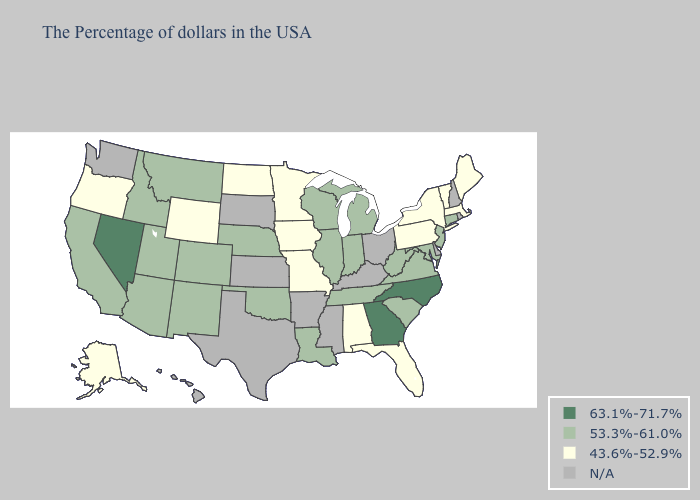What is the value of Indiana?
Keep it brief. 53.3%-61.0%. Does Minnesota have the highest value in the MidWest?
Write a very short answer. No. Does Alabama have the highest value in the USA?
Give a very brief answer. No. What is the highest value in the USA?
Short answer required. 63.1%-71.7%. What is the value of Kentucky?
Write a very short answer. N/A. What is the value of Kansas?
Answer briefly. N/A. Which states have the lowest value in the USA?
Write a very short answer. Maine, Massachusetts, Vermont, New York, Pennsylvania, Florida, Alabama, Missouri, Minnesota, Iowa, North Dakota, Wyoming, Oregon, Alaska. What is the highest value in the MidWest ?
Be succinct. 53.3%-61.0%. Does Nevada have the highest value in the USA?
Quick response, please. Yes. What is the highest value in states that border North Carolina?
Quick response, please. 63.1%-71.7%. What is the value of Pennsylvania?
Give a very brief answer. 43.6%-52.9%. What is the lowest value in the USA?
Answer briefly. 43.6%-52.9%. Does Nevada have the lowest value in the West?
Give a very brief answer. No. Does Illinois have the lowest value in the MidWest?
Give a very brief answer. No. 